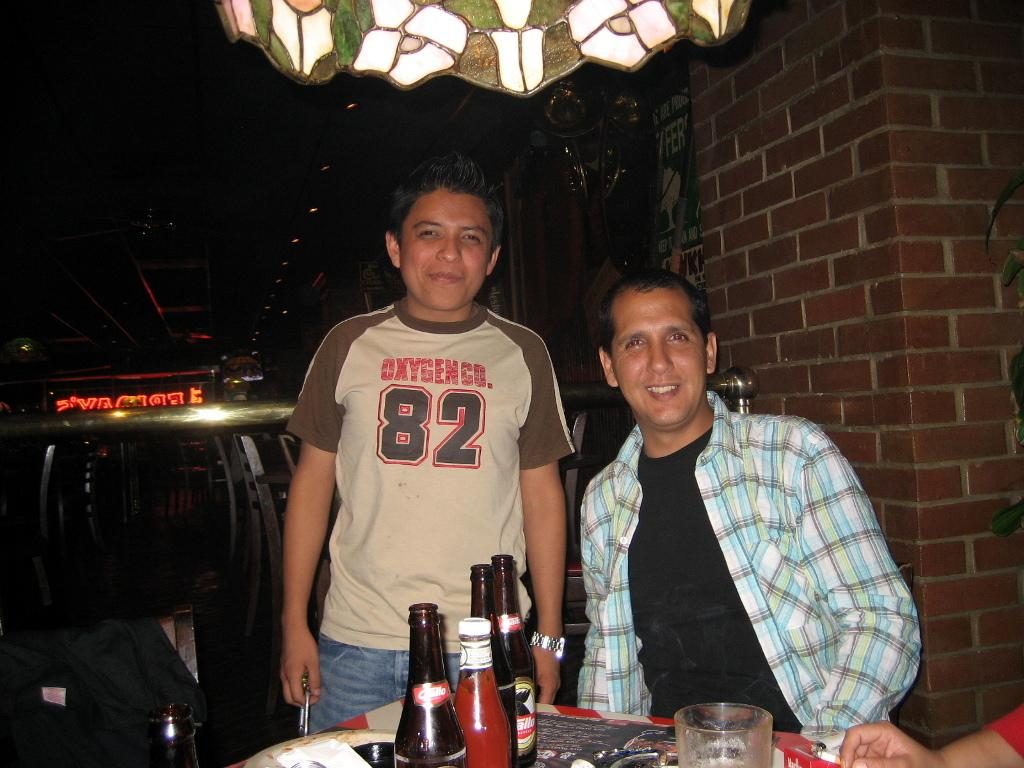What is the position of the man in the image? There is a man standing in the image. What is the man wearing in the image? The standing man is wearing a t-shirt and trousers. Can you describe the other man in the image? There is a man sitting in the image, and he is wearing a shirt and a black t-shirt. What can be seen on the table on the left side of the image? There are bottles on a table on the left side of the image. What type of flesh can be seen hanging from the ceiling in the image? There is no flesh hanging from the ceiling in the image. How many beads are present on the sitting man's necklace in the image? There is no necklace or beads visible on the sitting man in the image. 